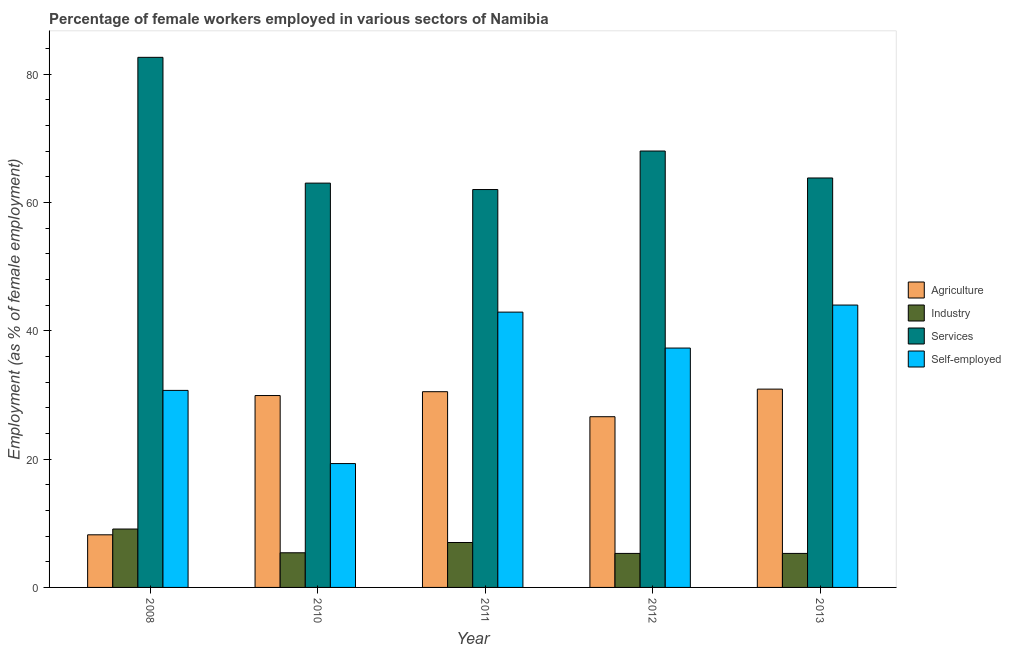How many different coloured bars are there?
Offer a very short reply. 4. How many groups of bars are there?
Make the answer very short. 5. Are the number of bars per tick equal to the number of legend labels?
Keep it short and to the point. Yes. Are the number of bars on each tick of the X-axis equal?
Keep it short and to the point. Yes. How many bars are there on the 4th tick from the right?
Provide a short and direct response. 4. What is the label of the 1st group of bars from the left?
Your answer should be compact. 2008. What is the percentage of self employed female workers in 2010?
Your answer should be very brief. 19.3. Across all years, what is the maximum percentage of female workers in agriculture?
Your answer should be very brief. 30.9. Across all years, what is the minimum percentage of self employed female workers?
Make the answer very short. 19.3. In which year was the percentage of female workers in agriculture minimum?
Keep it short and to the point. 2008. What is the total percentage of self employed female workers in the graph?
Ensure brevity in your answer.  174.2. What is the difference between the percentage of self employed female workers in 2008 and that in 2012?
Your response must be concise. -6.6. What is the difference between the percentage of female workers in industry in 2008 and the percentage of female workers in agriculture in 2013?
Your answer should be compact. 3.8. What is the average percentage of self employed female workers per year?
Ensure brevity in your answer.  34.84. In the year 2012, what is the difference between the percentage of female workers in agriculture and percentage of female workers in industry?
Your response must be concise. 0. What is the ratio of the percentage of female workers in services in 2011 to that in 2012?
Your answer should be compact. 0.91. Is the percentage of self employed female workers in 2008 less than that in 2010?
Give a very brief answer. No. What is the difference between the highest and the second highest percentage of female workers in services?
Offer a terse response. 14.6. What is the difference between the highest and the lowest percentage of female workers in agriculture?
Offer a very short reply. 22.7. In how many years, is the percentage of female workers in services greater than the average percentage of female workers in services taken over all years?
Keep it short and to the point. 2. Is the sum of the percentage of female workers in agriculture in 2010 and 2012 greater than the maximum percentage of female workers in services across all years?
Your answer should be compact. Yes. What does the 2nd bar from the left in 2008 represents?
Keep it short and to the point. Industry. What does the 2nd bar from the right in 2011 represents?
Offer a very short reply. Services. How many bars are there?
Offer a very short reply. 20. How many years are there in the graph?
Offer a terse response. 5. What is the difference between two consecutive major ticks on the Y-axis?
Ensure brevity in your answer.  20. Where does the legend appear in the graph?
Offer a very short reply. Center right. How many legend labels are there?
Your answer should be very brief. 4. How are the legend labels stacked?
Give a very brief answer. Vertical. What is the title of the graph?
Your answer should be very brief. Percentage of female workers employed in various sectors of Namibia. Does "Labor Taxes" appear as one of the legend labels in the graph?
Offer a very short reply. No. What is the label or title of the X-axis?
Offer a terse response. Year. What is the label or title of the Y-axis?
Give a very brief answer. Employment (as % of female employment). What is the Employment (as % of female employment) of Agriculture in 2008?
Your answer should be very brief. 8.2. What is the Employment (as % of female employment) in Industry in 2008?
Keep it short and to the point. 9.1. What is the Employment (as % of female employment) in Services in 2008?
Offer a very short reply. 82.6. What is the Employment (as % of female employment) in Self-employed in 2008?
Offer a very short reply. 30.7. What is the Employment (as % of female employment) in Agriculture in 2010?
Provide a short and direct response. 29.9. What is the Employment (as % of female employment) of Industry in 2010?
Keep it short and to the point. 5.4. What is the Employment (as % of female employment) of Self-employed in 2010?
Offer a terse response. 19.3. What is the Employment (as % of female employment) of Agriculture in 2011?
Provide a short and direct response. 30.5. What is the Employment (as % of female employment) in Services in 2011?
Keep it short and to the point. 62. What is the Employment (as % of female employment) in Self-employed in 2011?
Provide a succinct answer. 42.9. What is the Employment (as % of female employment) of Agriculture in 2012?
Make the answer very short. 26.6. What is the Employment (as % of female employment) in Industry in 2012?
Offer a terse response. 5.3. What is the Employment (as % of female employment) in Services in 2012?
Provide a succinct answer. 68. What is the Employment (as % of female employment) in Self-employed in 2012?
Give a very brief answer. 37.3. What is the Employment (as % of female employment) of Agriculture in 2013?
Offer a terse response. 30.9. What is the Employment (as % of female employment) of Industry in 2013?
Your answer should be very brief. 5.3. What is the Employment (as % of female employment) of Services in 2013?
Make the answer very short. 63.8. What is the Employment (as % of female employment) in Self-employed in 2013?
Keep it short and to the point. 44. Across all years, what is the maximum Employment (as % of female employment) of Agriculture?
Give a very brief answer. 30.9. Across all years, what is the maximum Employment (as % of female employment) of Industry?
Provide a short and direct response. 9.1. Across all years, what is the maximum Employment (as % of female employment) of Services?
Keep it short and to the point. 82.6. Across all years, what is the minimum Employment (as % of female employment) in Agriculture?
Give a very brief answer. 8.2. Across all years, what is the minimum Employment (as % of female employment) of Industry?
Provide a succinct answer. 5.3. Across all years, what is the minimum Employment (as % of female employment) in Self-employed?
Give a very brief answer. 19.3. What is the total Employment (as % of female employment) in Agriculture in the graph?
Provide a succinct answer. 126.1. What is the total Employment (as % of female employment) in Industry in the graph?
Offer a very short reply. 32.1. What is the total Employment (as % of female employment) of Services in the graph?
Your answer should be compact. 339.4. What is the total Employment (as % of female employment) in Self-employed in the graph?
Your answer should be very brief. 174.2. What is the difference between the Employment (as % of female employment) of Agriculture in 2008 and that in 2010?
Your answer should be very brief. -21.7. What is the difference between the Employment (as % of female employment) of Industry in 2008 and that in 2010?
Provide a succinct answer. 3.7. What is the difference between the Employment (as % of female employment) in Services in 2008 and that in 2010?
Provide a short and direct response. 19.6. What is the difference between the Employment (as % of female employment) of Self-employed in 2008 and that in 2010?
Your response must be concise. 11.4. What is the difference between the Employment (as % of female employment) in Agriculture in 2008 and that in 2011?
Give a very brief answer. -22.3. What is the difference between the Employment (as % of female employment) in Services in 2008 and that in 2011?
Offer a terse response. 20.6. What is the difference between the Employment (as % of female employment) in Self-employed in 2008 and that in 2011?
Provide a short and direct response. -12.2. What is the difference between the Employment (as % of female employment) of Agriculture in 2008 and that in 2012?
Ensure brevity in your answer.  -18.4. What is the difference between the Employment (as % of female employment) of Services in 2008 and that in 2012?
Your answer should be very brief. 14.6. What is the difference between the Employment (as % of female employment) in Self-employed in 2008 and that in 2012?
Ensure brevity in your answer.  -6.6. What is the difference between the Employment (as % of female employment) of Agriculture in 2008 and that in 2013?
Your answer should be compact. -22.7. What is the difference between the Employment (as % of female employment) in Industry in 2008 and that in 2013?
Provide a succinct answer. 3.8. What is the difference between the Employment (as % of female employment) in Industry in 2010 and that in 2011?
Make the answer very short. -1.6. What is the difference between the Employment (as % of female employment) in Self-employed in 2010 and that in 2011?
Your answer should be very brief. -23.6. What is the difference between the Employment (as % of female employment) of Services in 2010 and that in 2012?
Give a very brief answer. -5. What is the difference between the Employment (as % of female employment) of Services in 2010 and that in 2013?
Offer a very short reply. -0.8. What is the difference between the Employment (as % of female employment) in Self-employed in 2010 and that in 2013?
Offer a very short reply. -24.7. What is the difference between the Employment (as % of female employment) in Self-employed in 2011 and that in 2012?
Offer a terse response. 5.6. What is the difference between the Employment (as % of female employment) of Services in 2011 and that in 2013?
Your answer should be very brief. -1.8. What is the difference between the Employment (as % of female employment) of Self-employed in 2011 and that in 2013?
Give a very brief answer. -1.1. What is the difference between the Employment (as % of female employment) of Agriculture in 2012 and that in 2013?
Provide a short and direct response. -4.3. What is the difference between the Employment (as % of female employment) in Industry in 2012 and that in 2013?
Keep it short and to the point. 0. What is the difference between the Employment (as % of female employment) in Self-employed in 2012 and that in 2013?
Ensure brevity in your answer.  -6.7. What is the difference between the Employment (as % of female employment) in Agriculture in 2008 and the Employment (as % of female employment) in Services in 2010?
Ensure brevity in your answer.  -54.8. What is the difference between the Employment (as % of female employment) of Industry in 2008 and the Employment (as % of female employment) of Services in 2010?
Make the answer very short. -53.9. What is the difference between the Employment (as % of female employment) in Services in 2008 and the Employment (as % of female employment) in Self-employed in 2010?
Offer a very short reply. 63.3. What is the difference between the Employment (as % of female employment) of Agriculture in 2008 and the Employment (as % of female employment) of Industry in 2011?
Your response must be concise. 1.2. What is the difference between the Employment (as % of female employment) of Agriculture in 2008 and the Employment (as % of female employment) of Services in 2011?
Give a very brief answer. -53.8. What is the difference between the Employment (as % of female employment) in Agriculture in 2008 and the Employment (as % of female employment) in Self-employed in 2011?
Provide a short and direct response. -34.7. What is the difference between the Employment (as % of female employment) in Industry in 2008 and the Employment (as % of female employment) in Services in 2011?
Provide a succinct answer. -52.9. What is the difference between the Employment (as % of female employment) of Industry in 2008 and the Employment (as % of female employment) of Self-employed in 2011?
Offer a terse response. -33.8. What is the difference between the Employment (as % of female employment) of Services in 2008 and the Employment (as % of female employment) of Self-employed in 2011?
Provide a succinct answer. 39.7. What is the difference between the Employment (as % of female employment) in Agriculture in 2008 and the Employment (as % of female employment) in Services in 2012?
Your response must be concise. -59.8. What is the difference between the Employment (as % of female employment) of Agriculture in 2008 and the Employment (as % of female employment) of Self-employed in 2012?
Ensure brevity in your answer.  -29.1. What is the difference between the Employment (as % of female employment) of Industry in 2008 and the Employment (as % of female employment) of Services in 2012?
Your answer should be very brief. -58.9. What is the difference between the Employment (as % of female employment) of Industry in 2008 and the Employment (as % of female employment) of Self-employed in 2012?
Ensure brevity in your answer.  -28.2. What is the difference between the Employment (as % of female employment) of Services in 2008 and the Employment (as % of female employment) of Self-employed in 2012?
Provide a succinct answer. 45.3. What is the difference between the Employment (as % of female employment) in Agriculture in 2008 and the Employment (as % of female employment) in Services in 2013?
Provide a succinct answer. -55.6. What is the difference between the Employment (as % of female employment) in Agriculture in 2008 and the Employment (as % of female employment) in Self-employed in 2013?
Your response must be concise. -35.8. What is the difference between the Employment (as % of female employment) of Industry in 2008 and the Employment (as % of female employment) of Services in 2013?
Ensure brevity in your answer.  -54.7. What is the difference between the Employment (as % of female employment) in Industry in 2008 and the Employment (as % of female employment) in Self-employed in 2013?
Offer a terse response. -34.9. What is the difference between the Employment (as % of female employment) of Services in 2008 and the Employment (as % of female employment) of Self-employed in 2013?
Ensure brevity in your answer.  38.6. What is the difference between the Employment (as % of female employment) of Agriculture in 2010 and the Employment (as % of female employment) of Industry in 2011?
Your response must be concise. 22.9. What is the difference between the Employment (as % of female employment) in Agriculture in 2010 and the Employment (as % of female employment) in Services in 2011?
Provide a short and direct response. -32.1. What is the difference between the Employment (as % of female employment) of Industry in 2010 and the Employment (as % of female employment) of Services in 2011?
Make the answer very short. -56.6. What is the difference between the Employment (as % of female employment) of Industry in 2010 and the Employment (as % of female employment) of Self-employed in 2011?
Give a very brief answer. -37.5. What is the difference between the Employment (as % of female employment) in Services in 2010 and the Employment (as % of female employment) in Self-employed in 2011?
Your answer should be very brief. 20.1. What is the difference between the Employment (as % of female employment) of Agriculture in 2010 and the Employment (as % of female employment) of Industry in 2012?
Offer a very short reply. 24.6. What is the difference between the Employment (as % of female employment) in Agriculture in 2010 and the Employment (as % of female employment) in Services in 2012?
Make the answer very short. -38.1. What is the difference between the Employment (as % of female employment) in Industry in 2010 and the Employment (as % of female employment) in Services in 2012?
Give a very brief answer. -62.6. What is the difference between the Employment (as % of female employment) of Industry in 2010 and the Employment (as % of female employment) of Self-employed in 2012?
Ensure brevity in your answer.  -31.9. What is the difference between the Employment (as % of female employment) in Services in 2010 and the Employment (as % of female employment) in Self-employed in 2012?
Provide a succinct answer. 25.7. What is the difference between the Employment (as % of female employment) of Agriculture in 2010 and the Employment (as % of female employment) of Industry in 2013?
Offer a terse response. 24.6. What is the difference between the Employment (as % of female employment) in Agriculture in 2010 and the Employment (as % of female employment) in Services in 2013?
Give a very brief answer. -33.9. What is the difference between the Employment (as % of female employment) in Agriculture in 2010 and the Employment (as % of female employment) in Self-employed in 2013?
Your answer should be very brief. -14.1. What is the difference between the Employment (as % of female employment) in Industry in 2010 and the Employment (as % of female employment) in Services in 2013?
Your response must be concise. -58.4. What is the difference between the Employment (as % of female employment) in Industry in 2010 and the Employment (as % of female employment) in Self-employed in 2013?
Keep it short and to the point. -38.6. What is the difference between the Employment (as % of female employment) of Services in 2010 and the Employment (as % of female employment) of Self-employed in 2013?
Give a very brief answer. 19. What is the difference between the Employment (as % of female employment) in Agriculture in 2011 and the Employment (as % of female employment) in Industry in 2012?
Provide a succinct answer. 25.2. What is the difference between the Employment (as % of female employment) of Agriculture in 2011 and the Employment (as % of female employment) of Services in 2012?
Your response must be concise. -37.5. What is the difference between the Employment (as % of female employment) in Agriculture in 2011 and the Employment (as % of female employment) in Self-employed in 2012?
Your answer should be very brief. -6.8. What is the difference between the Employment (as % of female employment) of Industry in 2011 and the Employment (as % of female employment) of Services in 2012?
Keep it short and to the point. -61. What is the difference between the Employment (as % of female employment) of Industry in 2011 and the Employment (as % of female employment) of Self-employed in 2012?
Give a very brief answer. -30.3. What is the difference between the Employment (as % of female employment) in Services in 2011 and the Employment (as % of female employment) in Self-employed in 2012?
Offer a terse response. 24.7. What is the difference between the Employment (as % of female employment) in Agriculture in 2011 and the Employment (as % of female employment) in Industry in 2013?
Offer a terse response. 25.2. What is the difference between the Employment (as % of female employment) in Agriculture in 2011 and the Employment (as % of female employment) in Services in 2013?
Your answer should be compact. -33.3. What is the difference between the Employment (as % of female employment) in Industry in 2011 and the Employment (as % of female employment) in Services in 2013?
Offer a terse response. -56.8. What is the difference between the Employment (as % of female employment) of Industry in 2011 and the Employment (as % of female employment) of Self-employed in 2013?
Offer a very short reply. -37. What is the difference between the Employment (as % of female employment) in Services in 2011 and the Employment (as % of female employment) in Self-employed in 2013?
Keep it short and to the point. 18. What is the difference between the Employment (as % of female employment) in Agriculture in 2012 and the Employment (as % of female employment) in Industry in 2013?
Ensure brevity in your answer.  21.3. What is the difference between the Employment (as % of female employment) in Agriculture in 2012 and the Employment (as % of female employment) in Services in 2013?
Your answer should be compact. -37.2. What is the difference between the Employment (as % of female employment) in Agriculture in 2012 and the Employment (as % of female employment) in Self-employed in 2013?
Your response must be concise. -17.4. What is the difference between the Employment (as % of female employment) of Industry in 2012 and the Employment (as % of female employment) of Services in 2013?
Keep it short and to the point. -58.5. What is the difference between the Employment (as % of female employment) in Industry in 2012 and the Employment (as % of female employment) in Self-employed in 2013?
Keep it short and to the point. -38.7. What is the average Employment (as % of female employment) of Agriculture per year?
Offer a very short reply. 25.22. What is the average Employment (as % of female employment) in Industry per year?
Offer a very short reply. 6.42. What is the average Employment (as % of female employment) in Services per year?
Make the answer very short. 67.88. What is the average Employment (as % of female employment) in Self-employed per year?
Your answer should be very brief. 34.84. In the year 2008, what is the difference between the Employment (as % of female employment) in Agriculture and Employment (as % of female employment) in Industry?
Provide a short and direct response. -0.9. In the year 2008, what is the difference between the Employment (as % of female employment) in Agriculture and Employment (as % of female employment) in Services?
Your answer should be compact. -74.4. In the year 2008, what is the difference between the Employment (as % of female employment) of Agriculture and Employment (as % of female employment) of Self-employed?
Provide a short and direct response. -22.5. In the year 2008, what is the difference between the Employment (as % of female employment) of Industry and Employment (as % of female employment) of Services?
Provide a short and direct response. -73.5. In the year 2008, what is the difference between the Employment (as % of female employment) in Industry and Employment (as % of female employment) in Self-employed?
Your answer should be very brief. -21.6. In the year 2008, what is the difference between the Employment (as % of female employment) of Services and Employment (as % of female employment) of Self-employed?
Make the answer very short. 51.9. In the year 2010, what is the difference between the Employment (as % of female employment) of Agriculture and Employment (as % of female employment) of Services?
Your answer should be very brief. -33.1. In the year 2010, what is the difference between the Employment (as % of female employment) in Industry and Employment (as % of female employment) in Services?
Offer a terse response. -57.6. In the year 2010, what is the difference between the Employment (as % of female employment) of Industry and Employment (as % of female employment) of Self-employed?
Make the answer very short. -13.9. In the year 2010, what is the difference between the Employment (as % of female employment) of Services and Employment (as % of female employment) of Self-employed?
Your answer should be very brief. 43.7. In the year 2011, what is the difference between the Employment (as % of female employment) of Agriculture and Employment (as % of female employment) of Services?
Ensure brevity in your answer.  -31.5. In the year 2011, what is the difference between the Employment (as % of female employment) in Industry and Employment (as % of female employment) in Services?
Offer a very short reply. -55. In the year 2011, what is the difference between the Employment (as % of female employment) of Industry and Employment (as % of female employment) of Self-employed?
Give a very brief answer. -35.9. In the year 2012, what is the difference between the Employment (as % of female employment) of Agriculture and Employment (as % of female employment) of Industry?
Your response must be concise. 21.3. In the year 2012, what is the difference between the Employment (as % of female employment) in Agriculture and Employment (as % of female employment) in Services?
Provide a short and direct response. -41.4. In the year 2012, what is the difference between the Employment (as % of female employment) of Industry and Employment (as % of female employment) of Services?
Provide a succinct answer. -62.7. In the year 2012, what is the difference between the Employment (as % of female employment) of Industry and Employment (as % of female employment) of Self-employed?
Provide a short and direct response. -32. In the year 2012, what is the difference between the Employment (as % of female employment) in Services and Employment (as % of female employment) in Self-employed?
Your answer should be compact. 30.7. In the year 2013, what is the difference between the Employment (as % of female employment) of Agriculture and Employment (as % of female employment) of Industry?
Your answer should be compact. 25.6. In the year 2013, what is the difference between the Employment (as % of female employment) of Agriculture and Employment (as % of female employment) of Services?
Provide a short and direct response. -32.9. In the year 2013, what is the difference between the Employment (as % of female employment) of Agriculture and Employment (as % of female employment) of Self-employed?
Your answer should be compact. -13.1. In the year 2013, what is the difference between the Employment (as % of female employment) of Industry and Employment (as % of female employment) of Services?
Make the answer very short. -58.5. In the year 2013, what is the difference between the Employment (as % of female employment) in Industry and Employment (as % of female employment) in Self-employed?
Your answer should be compact. -38.7. In the year 2013, what is the difference between the Employment (as % of female employment) of Services and Employment (as % of female employment) of Self-employed?
Your answer should be compact. 19.8. What is the ratio of the Employment (as % of female employment) in Agriculture in 2008 to that in 2010?
Offer a very short reply. 0.27. What is the ratio of the Employment (as % of female employment) in Industry in 2008 to that in 2010?
Give a very brief answer. 1.69. What is the ratio of the Employment (as % of female employment) in Services in 2008 to that in 2010?
Offer a very short reply. 1.31. What is the ratio of the Employment (as % of female employment) in Self-employed in 2008 to that in 2010?
Provide a succinct answer. 1.59. What is the ratio of the Employment (as % of female employment) in Agriculture in 2008 to that in 2011?
Make the answer very short. 0.27. What is the ratio of the Employment (as % of female employment) in Industry in 2008 to that in 2011?
Give a very brief answer. 1.3. What is the ratio of the Employment (as % of female employment) in Services in 2008 to that in 2011?
Your response must be concise. 1.33. What is the ratio of the Employment (as % of female employment) of Self-employed in 2008 to that in 2011?
Offer a terse response. 0.72. What is the ratio of the Employment (as % of female employment) of Agriculture in 2008 to that in 2012?
Ensure brevity in your answer.  0.31. What is the ratio of the Employment (as % of female employment) in Industry in 2008 to that in 2012?
Provide a succinct answer. 1.72. What is the ratio of the Employment (as % of female employment) in Services in 2008 to that in 2012?
Offer a terse response. 1.21. What is the ratio of the Employment (as % of female employment) of Self-employed in 2008 to that in 2012?
Your answer should be very brief. 0.82. What is the ratio of the Employment (as % of female employment) of Agriculture in 2008 to that in 2013?
Offer a terse response. 0.27. What is the ratio of the Employment (as % of female employment) in Industry in 2008 to that in 2013?
Offer a terse response. 1.72. What is the ratio of the Employment (as % of female employment) in Services in 2008 to that in 2013?
Provide a short and direct response. 1.29. What is the ratio of the Employment (as % of female employment) in Self-employed in 2008 to that in 2013?
Your answer should be compact. 0.7. What is the ratio of the Employment (as % of female employment) of Agriculture in 2010 to that in 2011?
Offer a very short reply. 0.98. What is the ratio of the Employment (as % of female employment) of Industry in 2010 to that in 2011?
Ensure brevity in your answer.  0.77. What is the ratio of the Employment (as % of female employment) of Services in 2010 to that in 2011?
Your answer should be very brief. 1.02. What is the ratio of the Employment (as % of female employment) of Self-employed in 2010 to that in 2011?
Provide a succinct answer. 0.45. What is the ratio of the Employment (as % of female employment) of Agriculture in 2010 to that in 2012?
Your answer should be very brief. 1.12. What is the ratio of the Employment (as % of female employment) of Industry in 2010 to that in 2012?
Give a very brief answer. 1.02. What is the ratio of the Employment (as % of female employment) of Services in 2010 to that in 2012?
Ensure brevity in your answer.  0.93. What is the ratio of the Employment (as % of female employment) of Self-employed in 2010 to that in 2012?
Ensure brevity in your answer.  0.52. What is the ratio of the Employment (as % of female employment) of Agriculture in 2010 to that in 2013?
Make the answer very short. 0.97. What is the ratio of the Employment (as % of female employment) of Industry in 2010 to that in 2013?
Your answer should be very brief. 1.02. What is the ratio of the Employment (as % of female employment) in Services in 2010 to that in 2013?
Provide a succinct answer. 0.99. What is the ratio of the Employment (as % of female employment) in Self-employed in 2010 to that in 2013?
Your answer should be compact. 0.44. What is the ratio of the Employment (as % of female employment) of Agriculture in 2011 to that in 2012?
Provide a short and direct response. 1.15. What is the ratio of the Employment (as % of female employment) in Industry in 2011 to that in 2012?
Provide a succinct answer. 1.32. What is the ratio of the Employment (as % of female employment) of Services in 2011 to that in 2012?
Make the answer very short. 0.91. What is the ratio of the Employment (as % of female employment) of Self-employed in 2011 to that in 2012?
Ensure brevity in your answer.  1.15. What is the ratio of the Employment (as % of female employment) of Agriculture in 2011 to that in 2013?
Your answer should be compact. 0.99. What is the ratio of the Employment (as % of female employment) of Industry in 2011 to that in 2013?
Ensure brevity in your answer.  1.32. What is the ratio of the Employment (as % of female employment) in Services in 2011 to that in 2013?
Keep it short and to the point. 0.97. What is the ratio of the Employment (as % of female employment) in Self-employed in 2011 to that in 2013?
Your response must be concise. 0.97. What is the ratio of the Employment (as % of female employment) in Agriculture in 2012 to that in 2013?
Your answer should be very brief. 0.86. What is the ratio of the Employment (as % of female employment) in Industry in 2012 to that in 2013?
Keep it short and to the point. 1. What is the ratio of the Employment (as % of female employment) of Services in 2012 to that in 2013?
Keep it short and to the point. 1.07. What is the ratio of the Employment (as % of female employment) in Self-employed in 2012 to that in 2013?
Offer a terse response. 0.85. What is the difference between the highest and the second highest Employment (as % of female employment) of Agriculture?
Make the answer very short. 0.4. What is the difference between the highest and the second highest Employment (as % of female employment) in Self-employed?
Your response must be concise. 1.1. What is the difference between the highest and the lowest Employment (as % of female employment) in Agriculture?
Provide a succinct answer. 22.7. What is the difference between the highest and the lowest Employment (as % of female employment) in Industry?
Provide a short and direct response. 3.8. What is the difference between the highest and the lowest Employment (as % of female employment) in Services?
Offer a terse response. 20.6. What is the difference between the highest and the lowest Employment (as % of female employment) in Self-employed?
Provide a short and direct response. 24.7. 